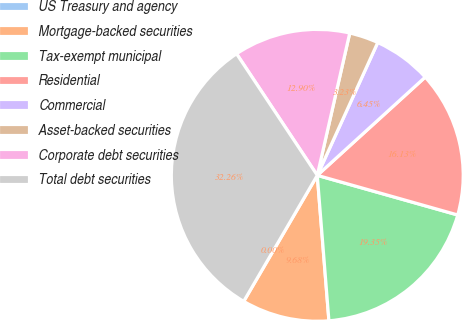Convert chart. <chart><loc_0><loc_0><loc_500><loc_500><pie_chart><fcel>US Treasury and agency<fcel>Mortgage-backed securities<fcel>Tax-exempt municipal<fcel>Residential<fcel>Commercial<fcel>Asset-backed securities<fcel>Corporate debt securities<fcel>Total debt securities<nl><fcel>0.0%<fcel>9.68%<fcel>19.35%<fcel>16.13%<fcel>6.45%<fcel>3.23%<fcel>12.9%<fcel>32.26%<nl></chart> 